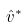Convert formula to latex. <formula><loc_0><loc_0><loc_500><loc_500>\hat { v } ^ { * }</formula> 